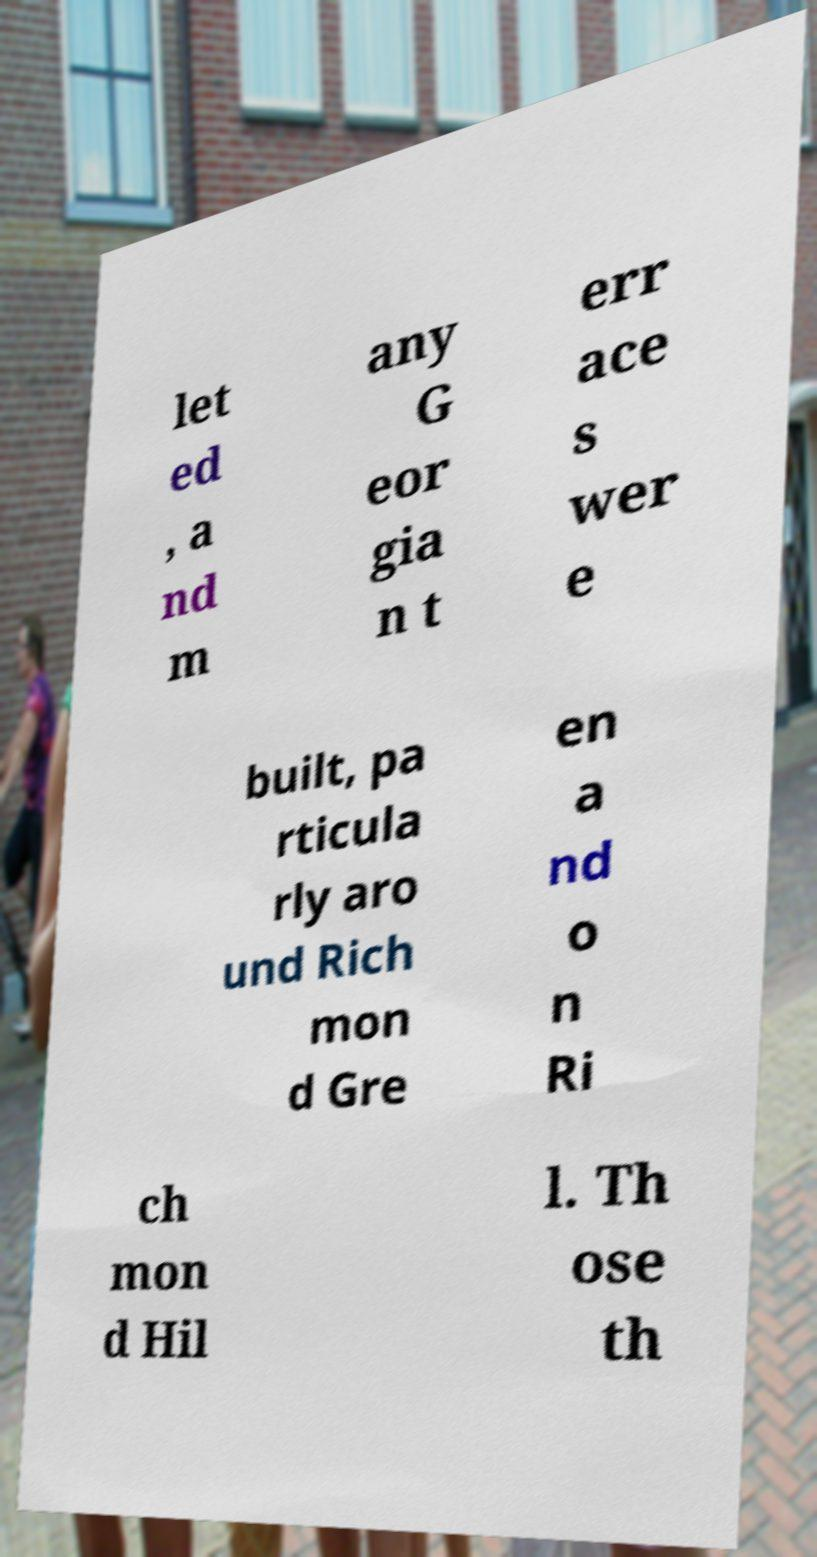Could you assist in decoding the text presented in this image and type it out clearly? let ed , a nd m any G eor gia n t err ace s wer e built, pa rticula rly aro und Rich mon d Gre en a nd o n Ri ch mon d Hil l. Th ose th 